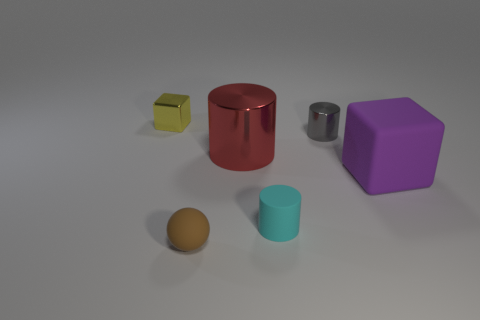Subtract all small rubber cylinders. How many cylinders are left? 2 Subtract 1 cylinders. How many cylinders are left? 2 Subtract all purple cubes. How many cubes are left? 1 Add 2 small blue cylinders. How many objects exist? 8 Subtract all spheres. How many objects are left? 5 Subtract all purple cylinders. How many yellow blocks are left? 1 Subtract all big matte things. Subtract all metallic cylinders. How many objects are left? 3 Add 1 tiny yellow shiny blocks. How many tiny yellow shiny blocks are left? 2 Add 5 large purple matte things. How many large purple matte things exist? 6 Subtract 0 blue cylinders. How many objects are left? 6 